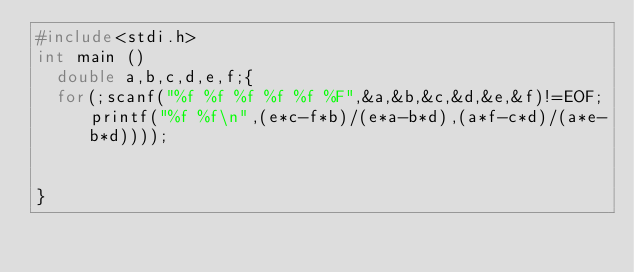<code> <loc_0><loc_0><loc_500><loc_500><_C_>#include<stdi.h>
int main ()
	double a,b,c,d,e,f;{
	for(;scanf("%f %f %f %f %f %F",&a,&b,&c,&d,&e,&f)!=EOF;printf("%f %f\n",(e*c-f*b)/(e*a-b*d),(a*f-c*d)/(a*e-b*d))));
	

}</code> 